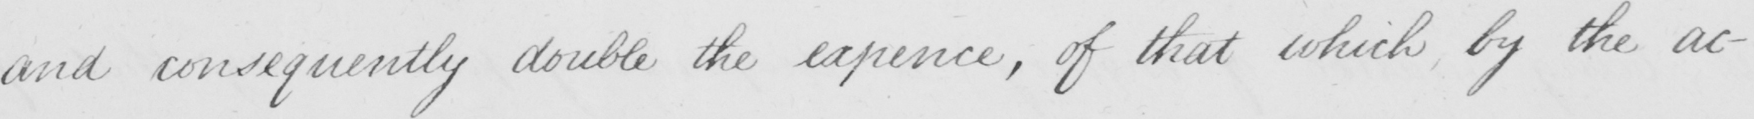Please transcribe the handwritten text in this image. and consequently double the expence , of that which , by the ac- 